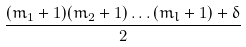Convert formula to latex. <formula><loc_0><loc_0><loc_500><loc_500>\frac { ( m _ { 1 } + 1 ) ( m _ { 2 } + 1 ) \dots ( m _ { l } + 1 ) + \delta } { 2 }</formula> 